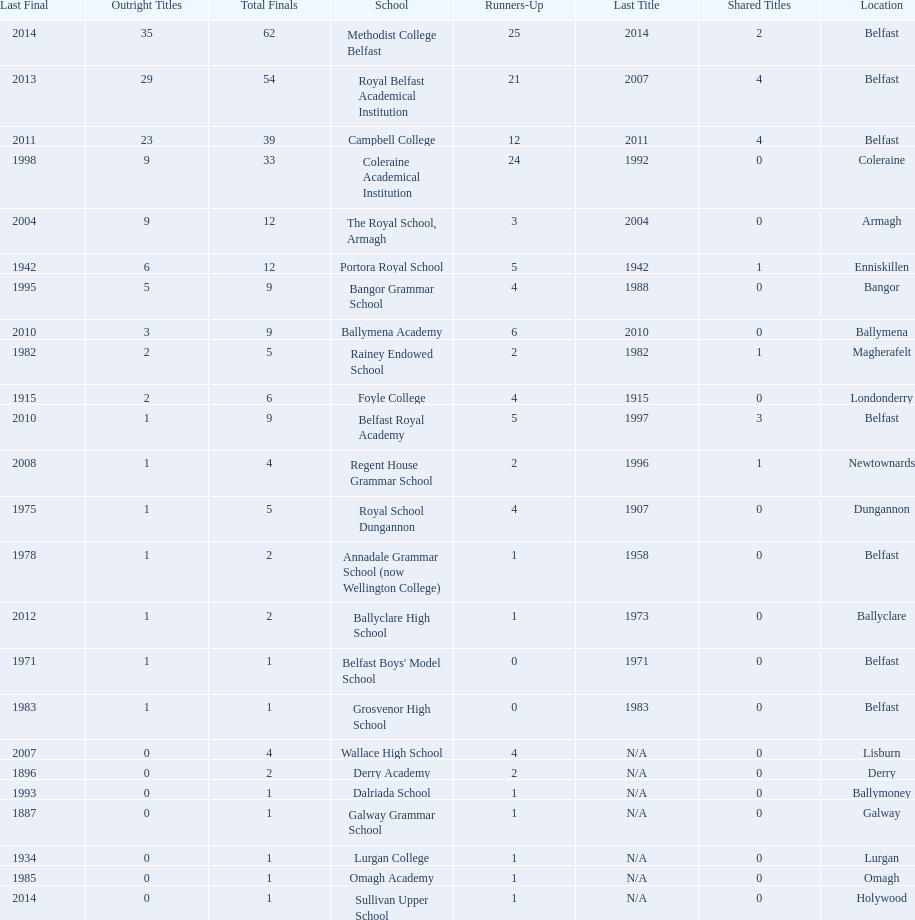How many schools are there? Methodist College Belfast, Royal Belfast Academical Institution, Campbell College, Coleraine Academical Institution, The Royal School, Armagh, Portora Royal School, Bangor Grammar School, Ballymena Academy, Rainey Endowed School, Foyle College, Belfast Royal Academy, Regent House Grammar School, Royal School Dungannon, Annadale Grammar School (now Wellington College), Ballyclare High School, Belfast Boys' Model School, Grosvenor High School, Wallace High School, Derry Academy, Dalriada School, Galway Grammar School, Lurgan College, Omagh Academy, Sullivan Upper School. How many outright titles does the coleraine academical institution have? 9. What other school has the same number of outright titles? The Royal School, Armagh. 